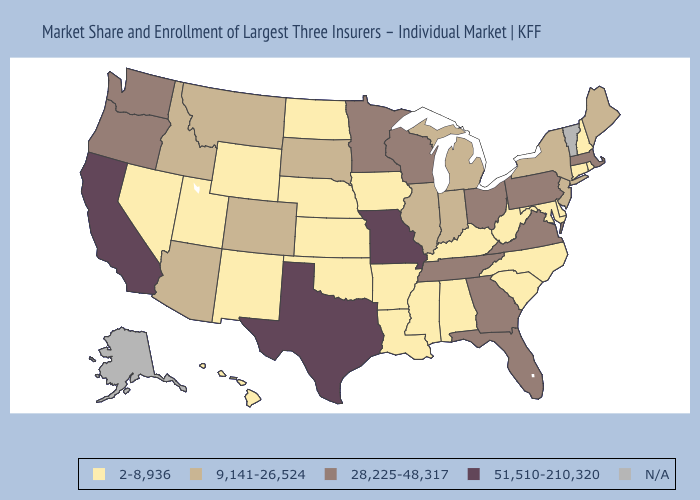What is the highest value in states that border Wisconsin?
Short answer required. 28,225-48,317. Among the states that border New Mexico , does Texas have the highest value?
Write a very short answer. Yes. Does Illinois have the lowest value in the MidWest?
Give a very brief answer. No. What is the highest value in states that border Florida?
Give a very brief answer. 28,225-48,317. What is the highest value in states that border Connecticut?
Concise answer only. 28,225-48,317. Name the states that have a value in the range 51,510-210,320?
Give a very brief answer. California, Missouri, Texas. What is the value of South Carolina?
Answer briefly. 2-8,936. What is the lowest value in the USA?
Quick response, please. 2-8,936. Does the first symbol in the legend represent the smallest category?
Keep it brief. Yes. Does Washington have the lowest value in the USA?
Answer briefly. No. Name the states that have a value in the range N/A?
Short answer required. Alaska, Vermont. What is the lowest value in states that border Indiana?
Concise answer only. 2-8,936. Which states have the highest value in the USA?
Short answer required. California, Missouri, Texas. 